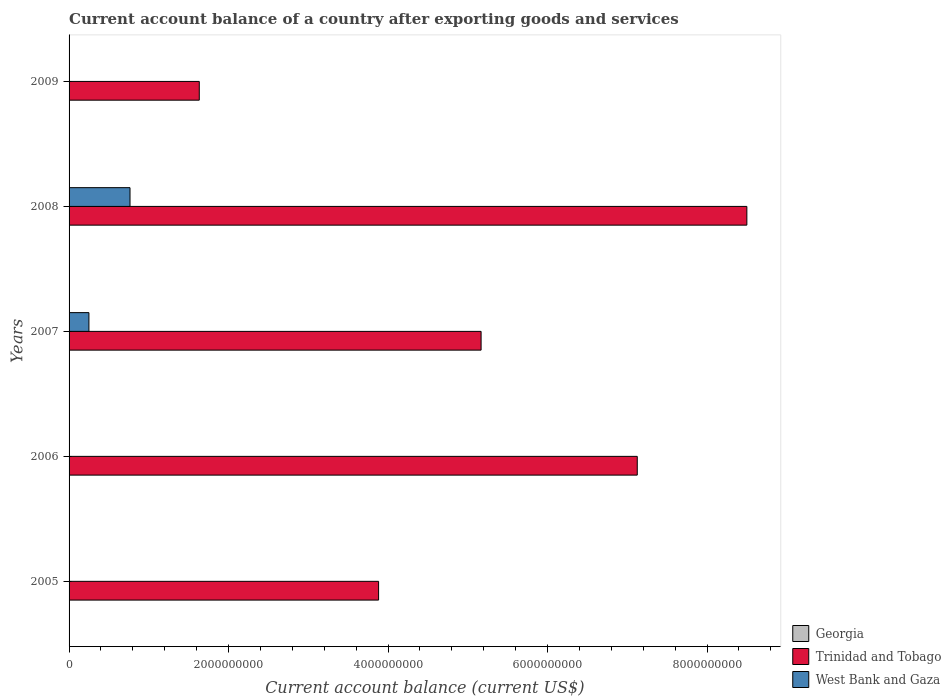How many different coloured bars are there?
Give a very brief answer. 2. How many bars are there on the 4th tick from the bottom?
Provide a short and direct response. 2. In how many cases, is the number of bars for a given year not equal to the number of legend labels?
Offer a terse response. 5. Across all years, what is the maximum account balance in Trinidad and Tobago?
Offer a terse response. 8.50e+09. Across all years, what is the minimum account balance in Trinidad and Tobago?
Provide a short and direct response. 1.63e+09. What is the total account balance in West Bank and Gaza in the graph?
Offer a very short reply. 1.01e+09. What is the difference between the account balance in Trinidad and Tobago in 2007 and that in 2009?
Give a very brief answer. 3.53e+09. What is the difference between the account balance in West Bank and Gaza in 2005 and the account balance in Georgia in 2008?
Keep it short and to the point. 0. What is the average account balance in Georgia per year?
Your response must be concise. 0. In the year 2008, what is the difference between the account balance in West Bank and Gaza and account balance in Trinidad and Tobago?
Provide a short and direct response. -7.73e+09. What is the ratio of the account balance in Trinidad and Tobago in 2005 to that in 2008?
Give a very brief answer. 0.46. Is the account balance in Trinidad and Tobago in 2005 less than that in 2006?
Your answer should be very brief. Yes. What is the difference between the highest and the second highest account balance in Trinidad and Tobago?
Make the answer very short. 1.37e+09. What is the difference between the highest and the lowest account balance in Trinidad and Tobago?
Make the answer very short. 6.87e+09. Is the sum of the account balance in Trinidad and Tobago in 2005 and 2007 greater than the maximum account balance in West Bank and Gaza across all years?
Keep it short and to the point. Yes. How many years are there in the graph?
Provide a short and direct response. 5. What is the difference between two consecutive major ticks on the X-axis?
Your answer should be very brief. 2.00e+09. Are the values on the major ticks of X-axis written in scientific E-notation?
Offer a terse response. No. Does the graph contain grids?
Keep it short and to the point. No. What is the title of the graph?
Keep it short and to the point. Current account balance of a country after exporting goods and services. What is the label or title of the X-axis?
Ensure brevity in your answer.  Current account balance (current US$). What is the label or title of the Y-axis?
Your answer should be compact. Years. What is the Current account balance (current US$) of Trinidad and Tobago in 2005?
Provide a short and direct response. 3.88e+09. What is the Current account balance (current US$) of Trinidad and Tobago in 2006?
Make the answer very short. 7.12e+09. What is the Current account balance (current US$) in West Bank and Gaza in 2006?
Your answer should be compact. 0. What is the Current account balance (current US$) in Georgia in 2007?
Your answer should be compact. 0. What is the Current account balance (current US$) of Trinidad and Tobago in 2007?
Your response must be concise. 5.17e+09. What is the Current account balance (current US$) of West Bank and Gaza in 2007?
Your answer should be very brief. 2.49e+08. What is the Current account balance (current US$) of Trinidad and Tobago in 2008?
Your answer should be very brief. 8.50e+09. What is the Current account balance (current US$) in West Bank and Gaza in 2008?
Ensure brevity in your answer.  7.64e+08. What is the Current account balance (current US$) of Georgia in 2009?
Make the answer very short. 0. What is the Current account balance (current US$) in Trinidad and Tobago in 2009?
Your answer should be very brief. 1.63e+09. What is the Current account balance (current US$) in West Bank and Gaza in 2009?
Provide a succinct answer. 0. Across all years, what is the maximum Current account balance (current US$) in Trinidad and Tobago?
Provide a succinct answer. 8.50e+09. Across all years, what is the maximum Current account balance (current US$) in West Bank and Gaza?
Offer a terse response. 7.64e+08. Across all years, what is the minimum Current account balance (current US$) in Trinidad and Tobago?
Provide a succinct answer. 1.63e+09. Across all years, what is the minimum Current account balance (current US$) in West Bank and Gaza?
Your answer should be very brief. 0. What is the total Current account balance (current US$) in Trinidad and Tobago in the graph?
Offer a terse response. 2.63e+1. What is the total Current account balance (current US$) in West Bank and Gaza in the graph?
Ensure brevity in your answer.  1.01e+09. What is the difference between the Current account balance (current US$) of Trinidad and Tobago in 2005 and that in 2006?
Provide a short and direct response. -3.24e+09. What is the difference between the Current account balance (current US$) of Trinidad and Tobago in 2005 and that in 2007?
Ensure brevity in your answer.  -1.29e+09. What is the difference between the Current account balance (current US$) in Trinidad and Tobago in 2005 and that in 2008?
Your response must be concise. -4.62e+09. What is the difference between the Current account balance (current US$) in Trinidad and Tobago in 2005 and that in 2009?
Your response must be concise. 2.25e+09. What is the difference between the Current account balance (current US$) in Trinidad and Tobago in 2006 and that in 2007?
Provide a succinct answer. 1.96e+09. What is the difference between the Current account balance (current US$) of Trinidad and Tobago in 2006 and that in 2008?
Provide a succinct answer. -1.37e+09. What is the difference between the Current account balance (current US$) of Trinidad and Tobago in 2006 and that in 2009?
Offer a terse response. 5.49e+09. What is the difference between the Current account balance (current US$) of Trinidad and Tobago in 2007 and that in 2008?
Ensure brevity in your answer.  -3.33e+09. What is the difference between the Current account balance (current US$) in West Bank and Gaza in 2007 and that in 2008?
Offer a terse response. -5.15e+08. What is the difference between the Current account balance (current US$) of Trinidad and Tobago in 2007 and that in 2009?
Provide a short and direct response. 3.53e+09. What is the difference between the Current account balance (current US$) in Trinidad and Tobago in 2008 and that in 2009?
Your answer should be compact. 6.87e+09. What is the difference between the Current account balance (current US$) in Trinidad and Tobago in 2005 and the Current account balance (current US$) in West Bank and Gaza in 2007?
Offer a very short reply. 3.63e+09. What is the difference between the Current account balance (current US$) of Trinidad and Tobago in 2005 and the Current account balance (current US$) of West Bank and Gaza in 2008?
Keep it short and to the point. 3.12e+09. What is the difference between the Current account balance (current US$) in Trinidad and Tobago in 2006 and the Current account balance (current US$) in West Bank and Gaza in 2007?
Give a very brief answer. 6.88e+09. What is the difference between the Current account balance (current US$) of Trinidad and Tobago in 2006 and the Current account balance (current US$) of West Bank and Gaza in 2008?
Provide a succinct answer. 6.36e+09. What is the difference between the Current account balance (current US$) of Trinidad and Tobago in 2007 and the Current account balance (current US$) of West Bank and Gaza in 2008?
Ensure brevity in your answer.  4.40e+09. What is the average Current account balance (current US$) in Georgia per year?
Provide a succinct answer. 0. What is the average Current account balance (current US$) of Trinidad and Tobago per year?
Provide a short and direct response. 5.26e+09. What is the average Current account balance (current US$) in West Bank and Gaza per year?
Offer a very short reply. 2.03e+08. In the year 2007, what is the difference between the Current account balance (current US$) in Trinidad and Tobago and Current account balance (current US$) in West Bank and Gaza?
Keep it short and to the point. 4.92e+09. In the year 2008, what is the difference between the Current account balance (current US$) in Trinidad and Tobago and Current account balance (current US$) in West Bank and Gaza?
Make the answer very short. 7.73e+09. What is the ratio of the Current account balance (current US$) of Trinidad and Tobago in 2005 to that in 2006?
Provide a short and direct response. 0.54. What is the ratio of the Current account balance (current US$) in Trinidad and Tobago in 2005 to that in 2007?
Ensure brevity in your answer.  0.75. What is the ratio of the Current account balance (current US$) in Trinidad and Tobago in 2005 to that in 2008?
Your response must be concise. 0.46. What is the ratio of the Current account balance (current US$) of Trinidad and Tobago in 2005 to that in 2009?
Offer a terse response. 2.38. What is the ratio of the Current account balance (current US$) in Trinidad and Tobago in 2006 to that in 2007?
Your response must be concise. 1.38. What is the ratio of the Current account balance (current US$) in Trinidad and Tobago in 2006 to that in 2008?
Offer a terse response. 0.84. What is the ratio of the Current account balance (current US$) in Trinidad and Tobago in 2006 to that in 2009?
Make the answer very short. 4.36. What is the ratio of the Current account balance (current US$) in Trinidad and Tobago in 2007 to that in 2008?
Ensure brevity in your answer.  0.61. What is the ratio of the Current account balance (current US$) in West Bank and Gaza in 2007 to that in 2008?
Give a very brief answer. 0.33. What is the ratio of the Current account balance (current US$) of Trinidad and Tobago in 2007 to that in 2009?
Provide a succinct answer. 3.16. What is the ratio of the Current account balance (current US$) of Trinidad and Tobago in 2008 to that in 2009?
Make the answer very short. 5.21. What is the difference between the highest and the second highest Current account balance (current US$) in Trinidad and Tobago?
Your answer should be very brief. 1.37e+09. What is the difference between the highest and the lowest Current account balance (current US$) of Trinidad and Tobago?
Offer a terse response. 6.87e+09. What is the difference between the highest and the lowest Current account balance (current US$) of West Bank and Gaza?
Your answer should be compact. 7.64e+08. 